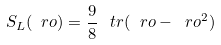Convert formula to latex. <formula><loc_0><loc_0><loc_500><loc_500>S _ { L } ( \ r o ) = \frac { 9 } { 8 } \, \ t r ( \ r o - \ r o ^ { 2 } )</formula> 